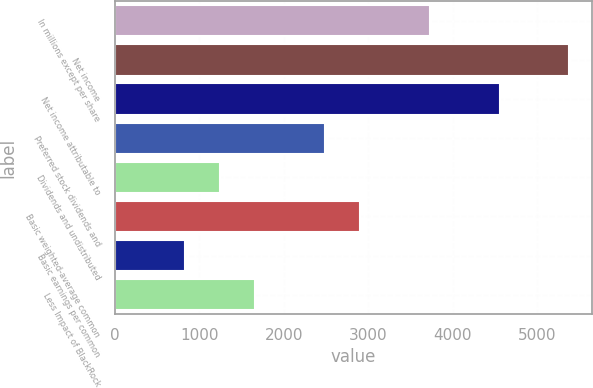<chart> <loc_0><loc_0><loc_500><loc_500><bar_chart><fcel>In millions except per share<fcel>Net income<fcel>Net income attributable to<fcel>Preferred stock dividends and<fcel>Dividends and undistributed<fcel>Basic weighted-average common<fcel>Basic earnings per common<fcel>Less Impact of BlackRock<nl><fcel>3729.4<fcel>5383.8<fcel>4556.6<fcel>2488.6<fcel>1247.8<fcel>2902.2<fcel>834.2<fcel>1661.4<nl></chart> 